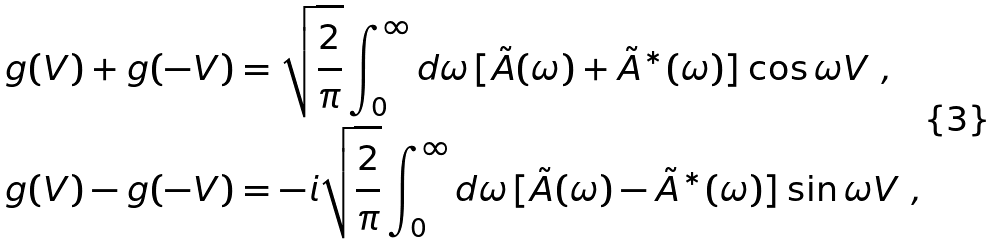Convert formula to latex. <formula><loc_0><loc_0><loc_500><loc_500>g ( V ) + g ( - V ) & = \sqrt { \frac { 2 } { \pi } } \int _ { 0 } ^ { \infty } d \omega \, [ \tilde { A } ( \omega ) + \tilde { A } ^ { * } ( \omega ) ] \cos \omega V \ , \\ g ( V ) - g ( - V ) & = - i \sqrt { \frac { 2 } { \pi } } \int _ { 0 } ^ { \infty } d \omega \, [ \tilde { A } ( \omega ) - \tilde { A } ^ { * } ( \omega ) ] \sin \omega V \ ,</formula> 